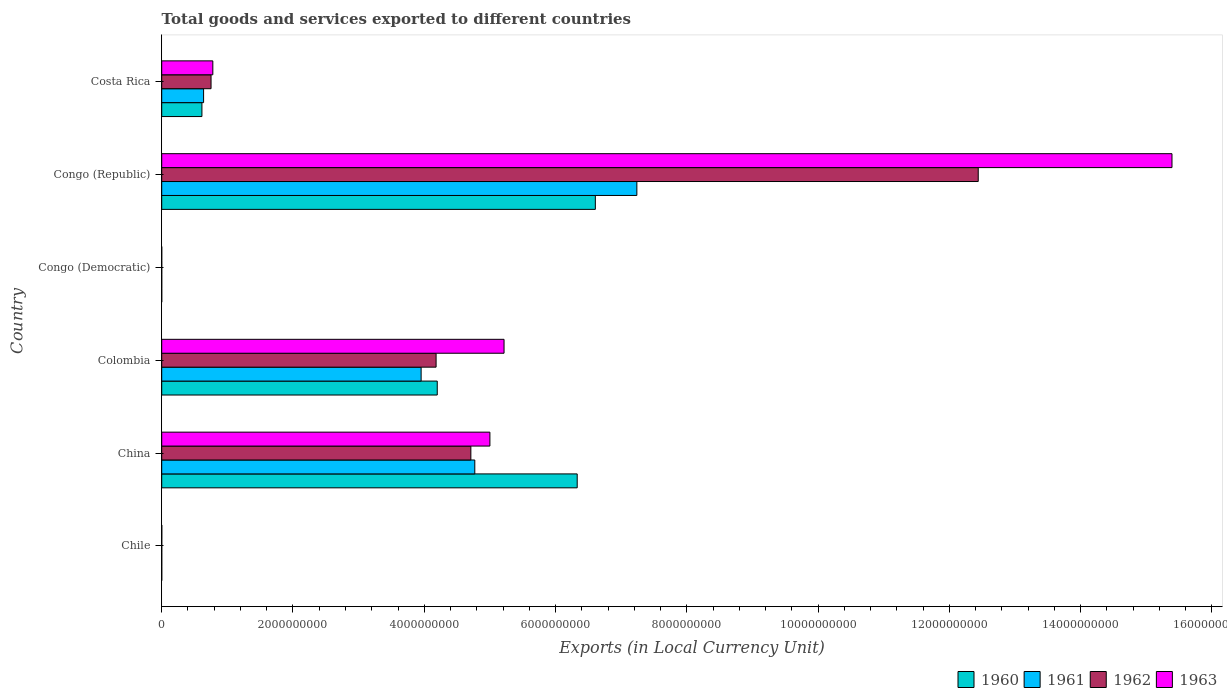How many different coloured bars are there?
Your response must be concise. 4. How many groups of bars are there?
Your response must be concise. 6. Are the number of bars per tick equal to the number of legend labels?
Make the answer very short. Yes. How many bars are there on the 3rd tick from the top?
Offer a terse response. 4. How many bars are there on the 1st tick from the bottom?
Make the answer very short. 4. What is the Amount of goods and services exports in 1960 in Congo (Democratic)?
Offer a terse response. 0. Across all countries, what is the maximum Amount of goods and services exports in 1963?
Your response must be concise. 1.54e+1. Across all countries, what is the minimum Amount of goods and services exports in 1962?
Make the answer very short. 6.15126409684308e-5. In which country was the Amount of goods and services exports in 1962 maximum?
Make the answer very short. Congo (Republic). In which country was the Amount of goods and services exports in 1961 minimum?
Ensure brevity in your answer.  Congo (Democratic). What is the total Amount of goods and services exports in 1960 in the graph?
Provide a succinct answer. 1.77e+1. What is the difference between the Amount of goods and services exports in 1960 in Chile and that in China?
Your answer should be compact. -6.33e+09. What is the difference between the Amount of goods and services exports in 1962 in Costa Rica and the Amount of goods and services exports in 1960 in China?
Offer a very short reply. -5.58e+09. What is the average Amount of goods and services exports in 1962 per country?
Provide a succinct answer. 3.68e+09. What is the difference between the Amount of goods and services exports in 1961 and Amount of goods and services exports in 1963 in Congo (Democratic)?
Make the answer very short. -0. In how many countries, is the Amount of goods and services exports in 1961 greater than 6800000000 LCU?
Provide a short and direct response. 1. What is the ratio of the Amount of goods and services exports in 1961 in China to that in Colombia?
Provide a short and direct response. 1.21. Is the Amount of goods and services exports in 1963 in Chile less than that in Costa Rica?
Make the answer very short. Yes. What is the difference between the highest and the second highest Amount of goods and services exports in 1962?
Your answer should be compact. 7.73e+09. What is the difference between the highest and the lowest Amount of goods and services exports in 1961?
Your answer should be very brief. 7.24e+09. Is the sum of the Amount of goods and services exports in 1963 in Colombia and Congo (Democratic) greater than the maximum Amount of goods and services exports in 1962 across all countries?
Your answer should be very brief. No. What does the 1st bar from the top in Costa Rica represents?
Offer a terse response. 1963. How many bars are there?
Give a very brief answer. 24. Are all the bars in the graph horizontal?
Provide a short and direct response. Yes. What is the difference between two consecutive major ticks on the X-axis?
Ensure brevity in your answer.  2.00e+09. Where does the legend appear in the graph?
Ensure brevity in your answer.  Bottom right. How many legend labels are there?
Provide a short and direct response. 4. What is the title of the graph?
Offer a terse response. Total goods and services exported to different countries. Does "1974" appear as one of the legend labels in the graph?
Provide a short and direct response. No. What is the label or title of the X-axis?
Ensure brevity in your answer.  Exports (in Local Currency Unit). What is the label or title of the Y-axis?
Provide a succinct answer. Country. What is the Exports (in Local Currency Unit) of 1961 in Chile?
Your response must be concise. 6.00e+05. What is the Exports (in Local Currency Unit) of 1963 in Chile?
Offer a very short reply. 1.10e+06. What is the Exports (in Local Currency Unit) in 1960 in China?
Your answer should be compact. 6.33e+09. What is the Exports (in Local Currency Unit) in 1961 in China?
Your answer should be very brief. 4.77e+09. What is the Exports (in Local Currency Unit) of 1962 in China?
Provide a succinct answer. 4.71e+09. What is the Exports (in Local Currency Unit) in 1960 in Colombia?
Your answer should be compact. 4.20e+09. What is the Exports (in Local Currency Unit) in 1961 in Colombia?
Keep it short and to the point. 3.95e+09. What is the Exports (in Local Currency Unit) in 1962 in Colombia?
Offer a terse response. 4.18e+09. What is the Exports (in Local Currency Unit) of 1963 in Colombia?
Make the answer very short. 5.22e+09. What is the Exports (in Local Currency Unit) in 1960 in Congo (Democratic)?
Make the answer very short. 0. What is the Exports (in Local Currency Unit) of 1961 in Congo (Democratic)?
Make the answer very short. 5.32500016561244e-5. What is the Exports (in Local Currency Unit) in 1962 in Congo (Democratic)?
Make the answer very short. 6.15126409684308e-5. What is the Exports (in Local Currency Unit) of 1963 in Congo (Democratic)?
Your answer should be compact. 0. What is the Exports (in Local Currency Unit) of 1960 in Congo (Republic)?
Give a very brief answer. 6.61e+09. What is the Exports (in Local Currency Unit) of 1961 in Congo (Republic)?
Keep it short and to the point. 7.24e+09. What is the Exports (in Local Currency Unit) in 1962 in Congo (Republic)?
Make the answer very short. 1.24e+1. What is the Exports (in Local Currency Unit) in 1963 in Congo (Republic)?
Offer a terse response. 1.54e+1. What is the Exports (in Local Currency Unit) in 1960 in Costa Rica?
Keep it short and to the point. 6.13e+08. What is the Exports (in Local Currency Unit) in 1961 in Costa Rica?
Provide a short and direct response. 6.38e+08. What is the Exports (in Local Currency Unit) in 1962 in Costa Rica?
Ensure brevity in your answer.  7.52e+08. What is the Exports (in Local Currency Unit) in 1963 in Costa Rica?
Offer a very short reply. 7.79e+08. Across all countries, what is the maximum Exports (in Local Currency Unit) of 1960?
Provide a short and direct response. 6.61e+09. Across all countries, what is the maximum Exports (in Local Currency Unit) in 1961?
Make the answer very short. 7.24e+09. Across all countries, what is the maximum Exports (in Local Currency Unit) in 1962?
Provide a succinct answer. 1.24e+1. Across all countries, what is the maximum Exports (in Local Currency Unit) in 1963?
Make the answer very short. 1.54e+1. Across all countries, what is the minimum Exports (in Local Currency Unit) in 1960?
Make the answer very short. 0. Across all countries, what is the minimum Exports (in Local Currency Unit) of 1961?
Keep it short and to the point. 5.32500016561244e-5. Across all countries, what is the minimum Exports (in Local Currency Unit) of 1962?
Provide a succinct answer. 6.15126409684308e-5. Across all countries, what is the minimum Exports (in Local Currency Unit) in 1963?
Ensure brevity in your answer.  0. What is the total Exports (in Local Currency Unit) of 1960 in the graph?
Provide a short and direct response. 1.77e+1. What is the total Exports (in Local Currency Unit) of 1961 in the graph?
Give a very brief answer. 1.66e+1. What is the total Exports (in Local Currency Unit) of 1962 in the graph?
Give a very brief answer. 2.21e+1. What is the total Exports (in Local Currency Unit) of 1963 in the graph?
Provide a succinct answer. 2.64e+1. What is the difference between the Exports (in Local Currency Unit) in 1960 in Chile and that in China?
Provide a short and direct response. -6.33e+09. What is the difference between the Exports (in Local Currency Unit) of 1961 in Chile and that in China?
Your answer should be very brief. -4.77e+09. What is the difference between the Exports (in Local Currency Unit) of 1962 in Chile and that in China?
Offer a very short reply. -4.71e+09. What is the difference between the Exports (in Local Currency Unit) in 1963 in Chile and that in China?
Your response must be concise. -5.00e+09. What is the difference between the Exports (in Local Currency Unit) of 1960 in Chile and that in Colombia?
Offer a terse response. -4.20e+09. What is the difference between the Exports (in Local Currency Unit) of 1961 in Chile and that in Colombia?
Give a very brief answer. -3.95e+09. What is the difference between the Exports (in Local Currency Unit) in 1962 in Chile and that in Colombia?
Your answer should be compact. -4.18e+09. What is the difference between the Exports (in Local Currency Unit) of 1963 in Chile and that in Colombia?
Your response must be concise. -5.21e+09. What is the difference between the Exports (in Local Currency Unit) of 1960 in Chile and that in Congo (Democratic)?
Offer a terse response. 6.00e+05. What is the difference between the Exports (in Local Currency Unit) in 1961 in Chile and that in Congo (Democratic)?
Ensure brevity in your answer.  6.00e+05. What is the difference between the Exports (in Local Currency Unit) in 1962 in Chile and that in Congo (Democratic)?
Your answer should be very brief. 7.00e+05. What is the difference between the Exports (in Local Currency Unit) in 1963 in Chile and that in Congo (Democratic)?
Offer a very short reply. 1.10e+06. What is the difference between the Exports (in Local Currency Unit) of 1960 in Chile and that in Congo (Republic)?
Offer a terse response. -6.61e+09. What is the difference between the Exports (in Local Currency Unit) of 1961 in Chile and that in Congo (Republic)?
Provide a short and direct response. -7.24e+09. What is the difference between the Exports (in Local Currency Unit) of 1962 in Chile and that in Congo (Republic)?
Provide a short and direct response. -1.24e+1. What is the difference between the Exports (in Local Currency Unit) of 1963 in Chile and that in Congo (Republic)?
Provide a short and direct response. -1.54e+1. What is the difference between the Exports (in Local Currency Unit) of 1960 in Chile and that in Costa Rica?
Ensure brevity in your answer.  -6.12e+08. What is the difference between the Exports (in Local Currency Unit) in 1961 in Chile and that in Costa Rica?
Make the answer very short. -6.37e+08. What is the difference between the Exports (in Local Currency Unit) of 1962 in Chile and that in Costa Rica?
Provide a short and direct response. -7.51e+08. What is the difference between the Exports (in Local Currency Unit) in 1963 in Chile and that in Costa Rica?
Make the answer very short. -7.78e+08. What is the difference between the Exports (in Local Currency Unit) in 1960 in China and that in Colombia?
Your answer should be very brief. 2.13e+09. What is the difference between the Exports (in Local Currency Unit) in 1961 in China and that in Colombia?
Your response must be concise. 8.18e+08. What is the difference between the Exports (in Local Currency Unit) in 1962 in China and that in Colombia?
Your answer should be very brief. 5.30e+08. What is the difference between the Exports (in Local Currency Unit) of 1963 in China and that in Colombia?
Keep it short and to the point. -2.16e+08. What is the difference between the Exports (in Local Currency Unit) in 1960 in China and that in Congo (Democratic)?
Your answer should be compact. 6.33e+09. What is the difference between the Exports (in Local Currency Unit) of 1961 in China and that in Congo (Democratic)?
Provide a succinct answer. 4.77e+09. What is the difference between the Exports (in Local Currency Unit) in 1962 in China and that in Congo (Democratic)?
Your answer should be very brief. 4.71e+09. What is the difference between the Exports (in Local Currency Unit) in 1963 in China and that in Congo (Democratic)?
Your answer should be very brief. 5.00e+09. What is the difference between the Exports (in Local Currency Unit) in 1960 in China and that in Congo (Republic)?
Your response must be concise. -2.76e+08. What is the difference between the Exports (in Local Currency Unit) of 1961 in China and that in Congo (Republic)?
Give a very brief answer. -2.47e+09. What is the difference between the Exports (in Local Currency Unit) of 1962 in China and that in Congo (Republic)?
Ensure brevity in your answer.  -7.73e+09. What is the difference between the Exports (in Local Currency Unit) of 1963 in China and that in Congo (Republic)?
Provide a succinct answer. -1.04e+1. What is the difference between the Exports (in Local Currency Unit) of 1960 in China and that in Costa Rica?
Ensure brevity in your answer.  5.72e+09. What is the difference between the Exports (in Local Currency Unit) in 1961 in China and that in Costa Rica?
Keep it short and to the point. 4.13e+09. What is the difference between the Exports (in Local Currency Unit) of 1962 in China and that in Costa Rica?
Offer a terse response. 3.96e+09. What is the difference between the Exports (in Local Currency Unit) of 1963 in China and that in Costa Rica?
Your answer should be compact. 4.22e+09. What is the difference between the Exports (in Local Currency Unit) in 1960 in Colombia and that in Congo (Democratic)?
Make the answer very short. 4.20e+09. What is the difference between the Exports (in Local Currency Unit) of 1961 in Colombia and that in Congo (Democratic)?
Your response must be concise. 3.95e+09. What is the difference between the Exports (in Local Currency Unit) in 1962 in Colombia and that in Congo (Democratic)?
Keep it short and to the point. 4.18e+09. What is the difference between the Exports (in Local Currency Unit) in 1963 in Colombia and that in Congo (Democratic)?
Your answer should be very brief. 5.22e+09. What is the difference between the Exports (in Local Currency Unit) of 1960 in Colombia and that in Congo (Republic)?
Provide a succinct answer. -2.41e+09. What is the difference between the Exports (in Local Currency Unit) of 1961 in Colombia and that in Congo (Republic)?
Your answer should be compact. -3.29e+09. What is the difference between the Exports (in Local Currency Unit) of 1962 in Colombia and that in Congo (Republic)?
Your response must be concise. -8.26e+09. What is the difference between the Exports (in Local Currency Unit) of 1963 in Colombia and that in Congo (Republic)?
Ensure brevity in your answer.  -1.02e+1. What is the difference between the Exports (in Local Currency Unit) of 1960 in Colombia and that in Costa Rica?
Provide a short and direct response. 3.59e+09. What is the difference between the Exports (in Local Currency Unit) in 1961 in Colombia and that in Costa Rica?
Your answer should be very brief. 3.31e+09. What is the difference between the Exports (in Local Currency Unit) in 1962 in Colombia and that in Costa Rica?
Your response must be concise. 3.43e+09. What is the difference between the Exports (in Local Currency Unit) in 1963 in Colombia and that in Costa Rica?
Give a very brief answer. 4.44e+09. What is the difference between the Exports (in Local Currency Unit) in 1960 in Congo (Democratic) and that in Congo (Republic)?
Your answer should be compact. -6.61e+09. What is the difference between the Exports (in Local Currency Unit) of 1961 in Congo (Democratic) and that in Congo (Republic)?
Your response must be concise. -7.24e+09. What is the difference between the Exports (in Local Currency Unit) of 1962 in Congo (Democratic) and that in Congo (Republic)?
Make the answer very short. -1.24e+1. What is the difference between the Exports (in Local Currency Unit) of 1963 in Congo (Democratic) and that in Congo (Republic)?
Offer a terse response. -1.54e+1. What is the difference between the Exports (in Local Currency Unit) in 1960 in Congo (Democratic) and that in Costa Rica?
Provide a short and direct response. -6.13e+08. What is the difference between the Exports (in Local Currency Unit) of 1961 in Congo (Democratic) and that in Costa Rica?
Your answer should be very brief. -6.38e+08. What is the difference between the Exports (in Local Currency Unit) in 1962 in Congo (Democratic) and that in Costa Rica?
Give a very brief answer. -7.52e+08. What is the difference between the Exports (in Local Currency Unit) of 1963 in Congo (Democratic) and that in Costa Rica?
Ensure brevity in your answer.  -7.79e+08. What is the difference between the Exports (in Local Currency Unit) in 1960 in Congo (Republic) and that in Costa Rica?
Provide a short and direct response. 5.99e+09. What is the difference between the Exports (in Local Currency Unit) of 1961 in Congo (Republic) and that in Costa Rica?
Keep it short and to the point. 6.60e+09. What is the difference between the Exports (in Local Currency Unit) in 1962 in Congo (Republic) and that in Costa Rica?
Your answer should be very brief. 1.17e+1. What is the difference between the Exports (in Local Currency Unit) in 1963 in Congo (Republic) and that in Costa Rica?
Offer a very short reply. 1.46e+1. What is the difference between the Exports (in Local Currency Unit) in 1960 in Chile and the Exports (in Local Currency Unit) in 1961 in China?
Make the answer very short. -4.77e+09. What is the difference between the Exports (in Local Currency Unit) in 1960 in Chile and the Exports (in Local Currency Unit) in 1962 in China?
Offer a terse response. -4.71e+09. What is the difference between the Exports (in Local Currency Unit) in 1960 in Chile and the Exports (in Local Currency Unit) in 1963 in China?
Ensure brevity in your answer.  -5.00e+09. What is the difference between the Exports (in Local Currency Unit) in 1961 in Chile and the Exports (in Local Currency Unit) in 1962 in China?
Keep it short and to the point. -4.71e+09. What is the difference between the Exports (in Local Currency Unit) in 1961 in Chile and the Exports (in Local Currency Unit) in 1963 in China?
Offer a very short reply. -5.00e+09. What is the difference between the Exports (in Local Currency Unit) in 1962 in Chile and the Exports (in Local Currency Unit) in 1963 in China?
Keep it short and to the point. -5.00e+09. What is the difference between the Exports (in Local Currency Unit) of 1960 in Chile and the Exports (in Local Currency Unit) of 1961 in Colombia?
Offer a very short reply. -3.95e+09. What is the difference between the Exports (in Local Currency Unit) of 1960 in Chile and the Exports (in Local Currency Unit) of 1962 in Colombia?
Keep it short and to the point. -4.18e+09. What is the difference between the Exports (in Local Currency Unit) in 1960 in Chile and the Exports (in Local Currency Unit) in 1963 in Colombia?
Your answer should be very brief. -5.21e+09. What is the difference between the Exports (in Local Currency Unit) of 1961 in Chile and the Exports (in Local Currency Unit) of 1962 in Colombia?
Make the answer very short. -4.18e+09. What is the difference between the Exports (in Local Currency Unit) in 1961 in Chile and the Exports (in Local Currency Unit) in 1963 in Colombia?
Provide a succinct answer. -5.21e+09. What is the difference between the Exports (in Local Currency Unit) of 1962 in Chile and the Exports (in Local Currency Unit) of 1963 in Colombia?
Provide a succinct answer. -5.21e+09. What is the difference between the Exports (in Local Currency Unit) in 1960 in Chile and the Exports (in Local Currency Unit) in 1961 in Congo (Democratic)?
Offer a terse response. 6.00e+05. What is the difference between the Exports (in Local Currency Unit) of 1960 in Chile and the Exports (in Local Currency Unit) of 1962 in Congo (Democratic)?
Give a very brief answer. 6.00e+05. What is the difference between the Exports (in Local Currency Unit) of 1960 in Chile and the Exports (in Local Currency Unit) of 1963 in Congo (Democratic)?
Your answer should be compact. 6.00e+05. What is the difference between the Exports (in Local Currency Unit) in 1961 in Chile and the Exports (in Local Currency Unit) in 1962 in Congo (Democratic)?
Make the answer very short. 6.00e+05. What is the difference between the Exports (in Local Currency Unit) of 1961 in Chile and the Exports (in Local Currency Unit) of 1963 in Congo (Democratic)?
Keep it short and to the point. 6.00e+05. What is the difference between the Exports (in Local Currency Unit) in 1962 in Chile and the Exports (in Local Currency Unit) in 1963 in Congo (Democratic)?
Keep it short and to the point. 7.00e+05. What is the difference between the Exports (in Local Currency Unit) of 1960 in Chile and the Exports (in Local Currency Unit) of 1961 in Congo (Republic)?
Offer a terse response. -7.24e+09. What is the difference between the Exports (in Local Currency Unit) of 1960 in Chile and the Exports (in Local Currency Unit) of 1962 in Congo (Republic)?
Your answer should be very brief. -1.24e+1. What is the difference between the Exports (in Local Currency Unit) of 1960 in Chile and the Exports (in Local Currency Unit) of 1963 in Congo (Republic)?
Provide a succinct answer. -1.54e+1. What is the difference between the Exports (in Local Currency Unit) of 1961 in Chile and the Exports (in Local Currency Unit) of 1962 in Congo (Republic)?
Make the answer very short. -1.24e+1. What is the difference between the Exports (in Local Currency Unit) of 1961 in Chile and the Exports (in Local Currency Unit) of 1963 in Congo (Republic)?
Offer a very short reply. -1.54e+1. What is the difference between the Exports (in Local Currency Unit) of 1962 in Chile and the Exports (in Local Currency Unit) of 1963 in Congo (Republic)?
Ensure brevity in your answer.  -1.54e+1. What is the difference between the Exports (in Local Currency Unit) of 1960 in Chile and the Exports (in Local Currency Unit) of 1961 in Costa Rica?
Give a very brief answer. -6.37e+08. What is the difference between the Exports (in Local Currency Unit) in 1960 in Chile and the Exports (in Local Currency Unit) in 1962 in Costa Rica?
Offer a terse response. -7.51e+08. What is the difference between the Exports (in Local Currency Unit) of 1960 in Chile and the Exports (in Local Currency Unit) of 1963 in Costa Rica?
Your answer should be compact. -7.78e+08. What is the difference between the Exports (in Local Currency Unit) in 1961 in Chile and the Exports (in Local Currency Unit) in 1962 in Costa Rica?
Make the answer very short. -7.51e+08. What is the difference between the Exports (in Local Currency Unit) in 1961 in Chile and the Exports (in Local Currency Unit) in 1963 in Costa Rica?
Make the answer very short. -7.78e+08. What is the difference between the Exports (in Local Currency Unit) in 1962 in Chile and the Exports (in Local Currency Unit) in 1963 in Costa Rica?
Provide a succinct answer. -7.78e+08. What is the difference between the Exports (in Local Currency Unit) of 1960 in China and the Exports (in Local Currency Unit) of 1961 in Colombia?
Offer a terse response. 2.38e+09. What is the difference between the Exports (in Local Currency Unit) in 1960 in China and the Exports (in Local Currency Unit) in 1962 in Colombia?
Your answer should be compact. 2.15e+09. What is the difference between the Exports (in Local Currency Unit) in 1960 in China and the Exports (in Local Currency Unit) in 1963 in Colombia?
Your response must be concise. 1.11e+09. What is the difference between the Exports (in Local Currency Unit) in 1961 in China and the Exports (in Local Currency Unit) in 1962 in Colombia?
Provide a short and direct response. 5.90e+08. What is the difference between the Exports (in Local Currency Unit) in 1961 in China and the Exports (in Local Currency Unit) in 1963 in Colombia?
Give a very brief answer. -4.46e+08. What is the difference between the Exports (in Local Currency Unit) in 1962 in China and the Exports (in Local Currency Unit) in 1963 in Colombia?
Your response must be concise. -5.06e+08. What is the difference between the Exports (in Local Currency Unit) of 1960 in China and the Exports (in Local Currency Unit) of 1961 in Congo (Democratic)?
Offer a terse response. 6.33e+09. What is the difference between the Exports (in Local Currency Unit) in 1960 in China and the Exports (in Local Currency Unit) in 1962 in Congo (Democratic)?
Provide a short and direct response. 6.33e+09. What is the difference between the Exports (in Local Currency Unit) in 1960 in China and the Exports (in Local Currency Unit) in 1963 in Congo (Democratic)?
Ensure brevity in your answer.  6.33e+09. What is the difference between the Exports (in Local Currency Unit) in 1961 in China and the Exports (in Local Currency Unit) in 1962 in Congo (Democratic)?
Offer a terse response. 4.77e+09. What is the difference between the Exports (in Local Currency Unit) of 1961 in China and the Exports (in Local Currency Unit) of 1963 in Congo (Democratic)?
Offer a very short reply. 4.77e+09. What is the difference between the Exports (in Local Currency Unit) of 1962 in China and the Exports (in Local Currency Unit) of 1963 in Congo (Democratic)?
Give a very brief answer. 4.71e+09. What is the difference between the Exports (in Local Currency Unit) in 1960 in China and the Exports (in Local Currency Unit) in 1961 in Congo (Republic)?
Offer a terse response. -9.09e+08. What is the difference between the Exports (in Local Currency Unit) in 1960 in China and the Exports (in Local Currency Unit) in 1962 in Congo (Republic)?
Provide a short and direct response. -6.11e+09. What is the difference between the Exports (in Local Currency Unit) in 1960 in China and the Exports (in Local Currency Unit) in 1963 in Congo (Republic)?
Keep it short and to the point. -9.06e+09. What is the difference between the Exports (in Local Currency Unit) of 1961 in China and the Exports (in Local Currency Unit) of 1962 in Congo (Republic)?
Make the answer very short. -7.67e+09. What is the difference between the Exports (in Local Currency Unit) of 1961 in China and the Exports (in Local Currency Unit) of 1963 in Congo (Republic)?
Your answer should be very brief. -1.06e+1. What is the difference between the Exports (in Local Currency Unit) of 1962 in China and the Exports (in Local Currency Unit) of 1963 in Congo (Republic)?
Your answer should be very brief. -1.07e+1. What is the difference between the Exports (in Local Currency Unit) of 1960 in China and the Exports (in Local Currency Unit) of 1961 in Costa Rica?
Your answer should be very brief. 5.69e+09. What is the difference between the Exports (in Local Currency Unit) of 1960 in China and the Exports (in Local Currency Unit) of 1962 in Costa Rica?
Your response must be concise. 5.58e+09. What is the difference between the Exports (in Local Currency Unit) of 1960 in China and the Exports (in Local Currency Unit) of 1963 in Costa Rica?
Provide a succinct answer. 5.55e+09. What is the difference between the Exports (in Local Currency Unit) of 1961 in China and the Exports (in Local Currency Unit) of 1962 in Costa Rica?
Your response must be concise. 4.02e+09. What is the difference between the Exports (in Local Currency Unit) in 1961 in China and the Exports (in Local Currency Unit) in 1963 in Costa Rica?
Give a very brief answer. 3.99e+09. What is the difference between the Exports (in Local Currency Unit) in 1962 in China and the Exports (in Local Currency Unit) in 1963 in Costa Rica?
Offer a terse response. 3.93e+09. What is the difference between the Exports (in Local Currency Unit) in 1960 in Colombia and the Exports (in Local Currency Unit) in 1961 in Congo (Democratic)?
Your answer should be compact. 4.20e+09. What is the difference between the Exports (in Local Currency Unit) in 1960 in Colombia and the Exports (in Local Currency Unit) in 1962 in Congo (Democratic)?
Make the answer very short. 4.20e+09. What is the difference between the Exports (in Local Currency Unit) of 1960 in Colombia and the Exports (in Local Currency Unit) of 1963 in Congo (Democratic)?
Your answer should be compact. 4.20e+09. What is the difference between the Exports (in Local Currency Unit) of 1961 in Colombia and the Exports (in Local Currency Unit) of 1962 in Congo (Democratic)?
Provide a short and direct response. 3.95e+09. What is the difference between the Exports (in Local Currency Unit) of 1961 in Colombia and the Exports (in Local Currency Unit) of 1963 in Congo (Democratic)?
Give a very brief answer. 3.95e+09. What is the difference between the Exports (in Local Currency Unit) of 1962 in Colombia and the Exports (in Local Currency Unit) of 1963 in Congo (Democratic)?
Your response must be concise. 4.18e+09. What is the difference between the Exports (in Local Currency Unit) of 1960 in Colombia and the Exports (in Local Currency Unit) of 1961 in Congo (Republic)?
Provide a succinct answer. -3.04e+09. What is the difference between the Exports (in Local Currency Unit) in 1960 in Colombia and the Exports (in Local Currency Unit) in 1962 in Congo (Republic)?
Provide a short and direct response. -8.24e+09. What is the difference between the Exports (in Local Currency Unit) in 1960 in Colombia and the Exports (in Local Currency Unit) in 1963 in Congo (Republic)?
Your response must be concise. -1.12e+1. What is the difference between the Exports (in Local Currency Unit) in 1961 in Colombia and the Exports (in Local Currency Unit) in 1962 in Congo (Republic)?
Offer a very short reply. -8.49e+09. What is the difference between the Exports (in Local Currency Unit) in 1961 in Colombia and the Exports (in Local Currency Unit) in 1963 in Congo (Republic)?
Make the answer very short. -1.14e+1. What is the difference between the Exports (in Local Currency Unit) in 1962 in Colombia and the Exports (in Local Currency Unit) in 1963 in Congo (Republic)?
Offer a terse response. -1.12e+1. What is the difference between the Exports (in Local Currency Unit) of 1960 in Colombia and the Exports (in Local Currency Unit) of 1961 in Costa Rica?
Give a very brief answer. 3.56e+09. What is the difference between the Exports (in Local Currency Unit) in 1960 in Colombia and the Exports (in Local Currency Unit) in 1962 in Costa Rica?
Your response must be concise. 3.45e+09. What is the difference between the Exports (in Local Currency Unit) in 1960 in Colombia and the Exports (in Local Currency Unit) in 1963 in Costa Rica?
Ensure brevity in your answer.  3.42e+09. What is the difference between the Exports (in Local Currency Unit) in 1961 in Colombia and the Exports (in Local Currency Unit) in 1962 in Costa Rica?
Your response must be concise. 3.20e+09. What is the difference between the Exports (in Local Currency Unit) of 1961 in Colombia and the Exports (in Local Currency Unit) of 1963 in Costa Rica?
Provide a succinct answer. 3.17e+09. What is the difference between the Exports (in Local Currency Unit) in 1962 in Colombia and the Exports (in Local Currency Unit) in 1963 in Costa Rica?
Make the answer very short. 3.40e+09. What is the difference between the Exports (in Local Currency Unit) in 1960 in Congo (Democratic) and the Exports (in Local Currency Unit) in 1961 in Congo (Republic)?
Offer a very short reply. -7.24e+09. What is the difference between the Exports (in Local Currency Unit) in 1960 in Congo (Democratic) and the Exports (in Local Currency Unit) in 1962 in Congo (Republic)?
Make the answer very short. -1.24e+1. What is the difference between the Exports (in Local Currency Unit) of 1960 in Congo (Democratic) and the Exports (in Local Currency Unit) of 1963 in Congo (Republic)?
Give a very brief answer. -1.54e+1. What is the difference between the Exports (in Local Currency Unit) of 1961 in Congo (Democratic) and the Exports (in Local Currency Unit) of 1962 in Congo (Republic)?
Your response must be concise. -1.24e+1. What is the difference between the Exports (in Local Currency Unit) of 1961 in Congo (Democratic) and the Exports (in Local Currency Unit) of 1963 in Congo (Republic)?
Keep it short and to the point. -1.54e+1. What is the difference between the Exports (in Local Currency Unit) of 1962 in Congo (Democratic) and the Exports (in Local Currency Unit) of 1963 in Congo (Republic)?
Keep it short and to the point. -1.54e+1. What is the difference between the Exports (in Local Currency Unit) in 1960 in Congo (Democratic) and the Exports (in Local Currency Unit) in 1961 in Costa Rica?
Offer a terse response. -6.38e+08. What is the difference between the Exports (in Local Currency Unit) in 1960 in Congo (Democratic) and the Exports (in Local Currency Unit) in 1962 in Costa Rica?
Give a very brief answer. -7.52e+08. What is the difference between the Exports (in Local Currency Unit) in 1960 in Congo (Democratic) and the Exports (in Local Currency Unit) in 1963 in Costa Rica?
Make the answer very short. -7.79e+08. What is the difference between the Exports (in Local Currency Unit) in 1961 in Congo (Democratic) and the Exports (in Local Currency Unit) in 1962 in Costa Rica?
Provide a short and direct response. -7.52e+08. What is the difference between the Exports (in Local Currency Unit) of 1961 in Congo (Democratic) and the Exports (in Local Currency Unit) of 1963 in Costa Rica?
Provide a succinct answer. -7.79e+08. What is the difference between the Exports (in Local Currency Unit) in 1962 in Congo (Democratic) and the Exports (in Local Currency Unit) in 1963 in Costa Rica?
Offer a very short reply. -7.79e+08. What is the difference between the Exports (in Local Currency Unit) in 1960 in Congo (Republic) and the Exports (in Local Currency Unit) in 1961 in Costa Rica?
Your answer should be compact. 5.97e+09. What is the difference between the Exports (in Local Currency Unit) of 1960 in Congo (Republic) and the Exports (in Local Currency Unit) of 1962 in Costa Rica?
Your response must be concise. 5.85e+09. What is the difference between the Exports (in Local Currency Unit) in 1960 in Congo (Republic) and the Exports (in Local Currency Unit) in 1963 in Costa Rica?
Keep it short and to the point. 5.83e+09. What is the difference between the Exports (in Local Currency Unit) of 1961 in Congo (Republic) and the Exports (in Local Currency Unit) of 1962 in Costa Rica?
Ensure brevity in your answer.  6.49e+09. What is the difference between the Exports (in Local Currency Unit) in 1961 in Congo (Republic) and the Exports (in Local Currency Unit) in 1963 in Costa Rica?
Your answer should be compact. 6.46e+09. What is the difference between the Exports (in Local Currency Unit) of 1962 in Congo (Republic) and the Exports (in Local Currency Unit) of 1963 in Costa Rica?
Provide a succinct answer. 1.17e+1. What is the average Exports (in Local Currency Unit) of 1960 per country?
Your answer should be compact. 2.96e+09. What is the average Exports (in Local Currency Unit) of 1961 per country?
Ensure brevity in your answer.  2.77e+09. What is the average Exports (in Local Currency Unit) of 1962 per country?
Your answer should be very brief. 3.68e+09. What is the average Exports (in Local Currency Unit) of 1963 per country?
Offer a terse response. 4.40e+09. What is the difference between the Exports (in Local Currency Unit) in 1960 and Exports (in Local Currency Unit) in 1961 in Chile?
Offer a very short reply. 0. What is the difference between the Exports (in Local Currency Unit) in 1960 and Exports (in Local Currency Unit) in 1963 in Chile?
Your answer should be compact. -5.00e+05. What is the difference between the Exports (in Local Currency Unit) of 1961 and Exports (in Local Currency Unit) of 1962 in Chile?
Your response must be concise. -1.00e+05. What is the difference between the Exports (in Local Currency Unit) of 1961 and Exports (in Local Currency Unit) of 1963 in Chile?
Your answer should be very brief. -5.00e+05. What is the difference between the Exports (in Local Currency Unit) in 1962 and Exports (in Local Currency Unit) in 1963 in Chile?
Offer a very short reply. -4.00e+05. What is the difference between the Exports (in Local Currency Unit) in 1960 and Exports (in Local Currency Unit) in 1961 in China?
Make the answer very short. 1.56e+09. What is the difference between the Exports (in Local Currency Unit) in 1960 and Exports (in Local Currency Unit) in 1962 in China?
Provide a short and direct response. 1.62e+09. What is the difference between the Exports (in Local Currency Unit) of 1960 and Exports (in Local Currency Unit) of 1963 in China?
Keep it short and to the point. 1.33e+09. What is the difference between the Exports (in Local Currency Unit) in 1961 and Exports (in Local Currency Unit) in 1962 in China?
Ensure brevity in your answer.  6.00e+07. What is the difference between the Exports (in Local Currency Unit) of 1961 and Exports (in Local Currency Unit) of 1963 in China?
Keep it short and to the point. -2.30e+08. What is the difference between the Exports (in Local Currency Unit) of 1962 and Exports (in Local Currency Unit) of 1963 in China?
Your answer should be very brief. -2.90e+08. What is the difference between the Exports (in Local Currency Unit) of 1960 and Exports (in Local Currency Unit) of 1961 in Colombia?
Provide a succinct answer. 2.46e+08. What is the difference between the Exports (in Local Currency Unit) of 1960 and Exports (in Local Currency Unit) of 1962 in Colombia?
Offer a very short reply. 1.74e+07. What is the difference between the Exports (in Local Currency Unit) of 1960 and Exports (in Local Currency Unit) of 1963 in Colombia?
Your answer should be compact. -1.02e+09. What is the difference between the Exports (in Local Currency Unit) in 1961 and Exports (in Local Currency Unit) in 1962 in Colombia?
Provide a short and direct response. -2.28e+08. What is the difference between the Exports (in Local Currency Unit) of 1961 and Exports (in Local Currency Unit) of 1963 in Colombia?
Your answer should be compact. -1.26e+09. What is the difference between the Exports (in Local Currency Unit) in 1962 and Exports (in Local Currency Unit) in 1963 in Colombia?
Your answer should be compact. -1.04e+09. What is the difference between the Exports (in Local Currency Unit) in 1960 and Exports (in Local Currency Unit) in 1961 in Congo (Democratic)?
Give a very brief answer. 0. What is the difference between the Exports (in Local Currency Unit) of 1960 and Exports (in Local Currency Unit) of 1962 in Congo (Democratic)?
Provide a short and direct response. 0. What is the difference between the Exports (in Local Currency Unit) in 1960 and Exports (in Local Currency Unit) in 1963 in Congo (Democratic)?
Offer a very short reply. -0. What is the difference between the Exports (in Local Currency Unit) of 1961 and Exports (in Local Currency Unit) of 1963 in Congo (Democratic)?
Keep it short and to the point. -0. What is the difference between the Exports (in Local Currency Unit) in 1962 and Exports (in Local Currency Unit) in 1963 in Congo (Democratic)?
Your answer should be very brief. -0. What is the difference between the Exports (in Local Currency Unit) of 1960 and Exports (in Local Currency Unit) of 1961 in Congo (Republic)?
Your response must be concise. -6.33e+08. What is the difference between the Exports (in Local Currency Unit) in 1960 and Exports (in Local Currency Unit) in 1962 in Congo (Republic)?
Offer a terse response. -5.83e+09. What is the difference between the Exports (in Local Currency Unit) of 1960 and Exports (in Local Currency Unit) of 1963 in Congo (Republic)?
Your answer should be compact. -8.79e+09. What is the difference between the Exports (in Local Currency Unit) in 1961 and Exports (in Local Currency Unit) in 1962 in Congo (Republic)?
Ensure brevity in your answer.  -5.20e+09. What is the difference between the Exports (in Local Currency Unit) of 1961 and Exports (in Local Currency Unit) of 1963 in Congo (Republic)?
Keep it short and to the point. -8.15e+09. What is the difference between the Exports (in Local Currency Unit) of 1962 and Exports (in Local Currency Unit) of 1963 in Congo (Republic)?
Provide a short and direct response. -2.95e+09. What is the difference between the Exports (in Local Currency Unit) in 1960 and Exports (in Local Currency Unit) in 1961 in Costa Rica?
Provide a short and direct response. -2.54e+07. What is the difference between the Exports (in Local Currency Unit) in 1960 and Exports (in Local Currency Unit) in 1962 in Costa Rica?
Ensure brevity in your answer.  -1.39e+08. What is the difference between the Exports (in Local Currency Unit) in 1960 and Exports (in Local Currency Unit) in 1963 in Costa Rica?
Offer a very short reply. -1.66e+08. What is the difference between the Exports (in Local Currency Unit) in 1961 and Exports (in Local Currency Unit) in 1962 in Costa Rica?
Provide a short and direct response. -1.14e+08. What is the difference between the Exports (in Local Currency Unit) in 1961 and Exports (in Local Currency Unit) in 1963 in Costa Rica?
Provide a succinct answer. -1.41e+08. What is the difference between the Exports (in Local Currency Unit) of 1962 and Exports (in Local Currency Unit) of 1963 in Costa Rica?
Keep it short and to the point. -2.71e+07. What is the ratio of the Exports (in Local Currency Unit) of 1963 in Chile to that in China?
Keep it short and to the point. 0. What is the ratio of the Exports (in Local Currency Unit) of 1961 in Chile to that in Colombia?
Give a very brief answer. 0. What is the ratio of the Exports (in Local Currency Unit) of 1962 in Chile to that in Colombia?
Your answer should be compact. 0. What is the ratio of the Exports (in Local Currency Unit) of 1963 in Chile to that in Colombia?
Provide a short and direct response. 0. What is the ratio of the Exports (in Local Currency Unit) in 1960 in Chile to that in Congo (Democratic)?
Give a very brief answer. 5.55e+09. What is the ratio of the Exports (in Local Currency Unit) in 1961 in Chile to that in Congo (Democratic)?
Give a very brief answer. 1.13e+1. What is the ratio of the Exports (in Local Currency Unit) in 1962 in Chile to that in Congo (Democratic)?
Offer a very short reply. 1.14e+1. What is the ratio of the Exports (in Local Currency Unit) of 1963 in Chile to that in Congo (Democratic)?
Make the answer very short. 2.21e+09. What is the ratio of the Exports (in Local Currency Unit) of 1963 in Chile to that in Congo (Republic)?
Offer a very short reply. 0. What is the ratio of the Exports (in Local Currency Unit) of 1961 in Chile to that in Costa Rica?
Keep it short and to the point. 0. What is the ratio of the Exports (in Local Currency Unit) of 1962 in Chile to that in Costa Rica?
Make the answer very short. 0. What is the ratio of the Exports (in Local Currency Unit) in 1963 in Chile to that in Costa Rica?
Keep it short and to the point. 0. What is the ratio of the Exports (in Local Currency Unit) in 1960 in China to that in Colombia?
Your answer should be compact. 1.51. What is the ratio of the Exports (in Local Currency Unit) of 1961 in China to that in Colombia?
Provide a succinct answer. 1.21. What is the ratio of the Exports (in Local Currency Unit) of 1962 in China to that in Colombia?
Ensure brevity in your answer.  1.13. What is the ratio of the Exports (in Local Currency Unit) of 1963 in China to that in Colombia?
Make the answer very short. 0.96. What is the ratio of the Exports (in Local Currency Unit) of 1960 in China to that in Congo (Democratic)?
Your response must be concise. 5.86e+13. What is the ratio of the Exports (in Local Currency Unit) in 1961 in China to that in Congo (Democratic)?
Ensure brevity in your answer.  8.96e+13. What is the ratio of the Exports (in Local Currency Unit) in 1962 in China to that in Congo (Democratic)?
Provide a short and direct response. 7.66e+13. What is the ratio of the Exports (in Local Currency Unit) in 1963 in China to that in Congo (Democratic)?
Offer a very short reply. 1.00e+13. What is the ratio of the Exports (in Local Currency Unit) of 1960 in China to that in Congo (Republic)?
Provide a succinct answer. 0.96. What is the ratio of the Exports (in Local Currency Unit) in 1961 in China to that in Congo (Republic)?
Ensure brevity in your answer.  0.66. What is the ratio of the Exports (in Local Currency Unit) in 1962 in China to that in Congo (Republic)?
Give a very brief answer. 0.38. What is the ratio of the Exports (in Local Currency Unit) of 1963 in China to that in Congo (Republic)?
Your response must be concise. 0.32. What is the ratio of the Exports (in Local Currency Unit) of 1960 in China to that in Costa Rica?
Your answer should be very brief. 10.33. What is the ratio of the Exports (in Local Currency Unit) in 1961 in China to that in Costa Rica?
Your answer should be compact. 7.48. What is the ratio of the Exports (in Local Currency Unit) in 1962 in China to that in Costa Rica?
Provide a short and direct response. 6.27. What is the ratio of the Exports (in Local Currency Unit) of 1963 in China to that in Costa Rica?
Give a very brief answer. 6.42. What is the ratio of the Exports (in Local Currency Unit) in 1960 in Colombia to that in Congo (Democratic)?
Your answer should be very brief. 3.89e+13. What is the ratio of the Exports (in Local Currency Unit) in 1961 in Colombia to that in Congo (Democratic)?
Your response must be concise. 7.42e+13. What is the ratio of the Exports (in Local Currency Unit) in 1962 in Colombia to that in Congo (Democratic)?
Make the answer very short. 6.80e+13. What is the ratio of the Exports (in Local Currency Unit) in 1963 in Colombia to that in Congo (Democratic)?
Give a very brief answer. 1.05e+13. What is the ratio of the Exports (in Local Currency Unit) in 1960 in Colombia to that in Congo (Republic)?
Provide a succinct answer. 0.64. What is the ratio of the Exports (in Local Currency Unit) in 1961 in Colombia to that in Congo (Republic)?
Keep it short and to the point. 0.55. What is the ratio of the Exports (in Local Currency Unit) of 1962 in Colombia to that in Congo (Republic)?
Give a very brief answer. 0.34. What is the ratio of the Exports (in Local Currency Unit) in 1963 in Colombia to that in Congo (Republic)?
Give a very brief answer. 0.34. What is the ratio of the Exports (in Local Currency Unit) in 1960 in Colombia to that in Costa Rica?
Make the answer very short. 6.85. What is the ratio of the Exports (in Local Currency Unit) of 1961 in Colombia to that in Costa Rica?
Provide a succinct answer. 6.19. What is the ratio of the Exports (in Local Currency Unit) in 1962 in Colombia to that in Costa Rica?
Keep it short and to the point. 5.56. What is the ratio of the Exports (in Local Currency Unit) in 1963 in Colombia to that in Costa Rica?
Give a very brief answer. 6.7. What is the ratio of the Exports (in Local Currency Unit) of 1960 in Congo (Democratic) to that in Congo (Republic)?
Provide a succinct answer. 0. What is the ratio of the Exports (in Local Currency Unit) of 1961 in Congo (Democratic) to that in Congo (Republic)?
Offer a very short reply. 0. What is the ratio of the Exports (in Local Currency Unit) of 1963 in Congo (Democratic) to that in Congo (Republic)?
Offer a very short reply. 0. What is the ratio of the Exports (in Local Currency Unit) in 1963 in Congo (Democratic) to that in Costa Rica?
Your response must be concise. 0. What is the ratio of the Exports (in Local Currency Unit) in 1960 in Congo (Republic) to that in Costa Rica?
Offer a very short reply. 10.78. What is the ratio of the Exports (in Local Currency Unit) of 1961 in Congo (Republic) to that in Costa Rica?
Provide a succinct answer. 11.35. What is the ratio of the Exports (in Local Currency Unit) of 1962 in Congo (Republic) to that in Costa Rica?
Offer a very short reply. 16.55. What is the ratio of the Exports (in Local Currency Unit) in 1963 in Congo (Republic) to that in Costa Rica?
Keep it short and to the point. 19.76. What is the difference between the highest and the second highest Exports (in Local Currency Unit) of 1960?
Your answer should be compact. 2.76e+08. What is the difference between the highest and the second highest Exports (in Local Currency Unit) in 1961?
Your answer should be very brief. 2.47e+09. What is the difference between the highest and the second highest Exports (in Local Currency Unit) in 1962?
Ensure brevity in your answer.  7.73e+09. What is the difference between the highest and the second highest Exports (in Local Currency Unit) of 1963?
Ensure brevity in your answer.  1.02e+1. What is the difference between the highest and the lowest Exports (in Local Currency Unit) of 1960?
Ensure brevity in your answer.  6.61e+09. What is the difference between the highest and the lowest Exports (in Local Currency Unit) of 1961?
Offer a terse response. 7.24e+09. What is the difference between the highest and the lowest Exports (in Local Currency Unit) in 1962?
Your answer should be very brief. 1.24e+1. What is the difference between the highest and the lowest Exports (in Local Currency Unit) of 1963?
Offer a terse response. 1.54e+1. 